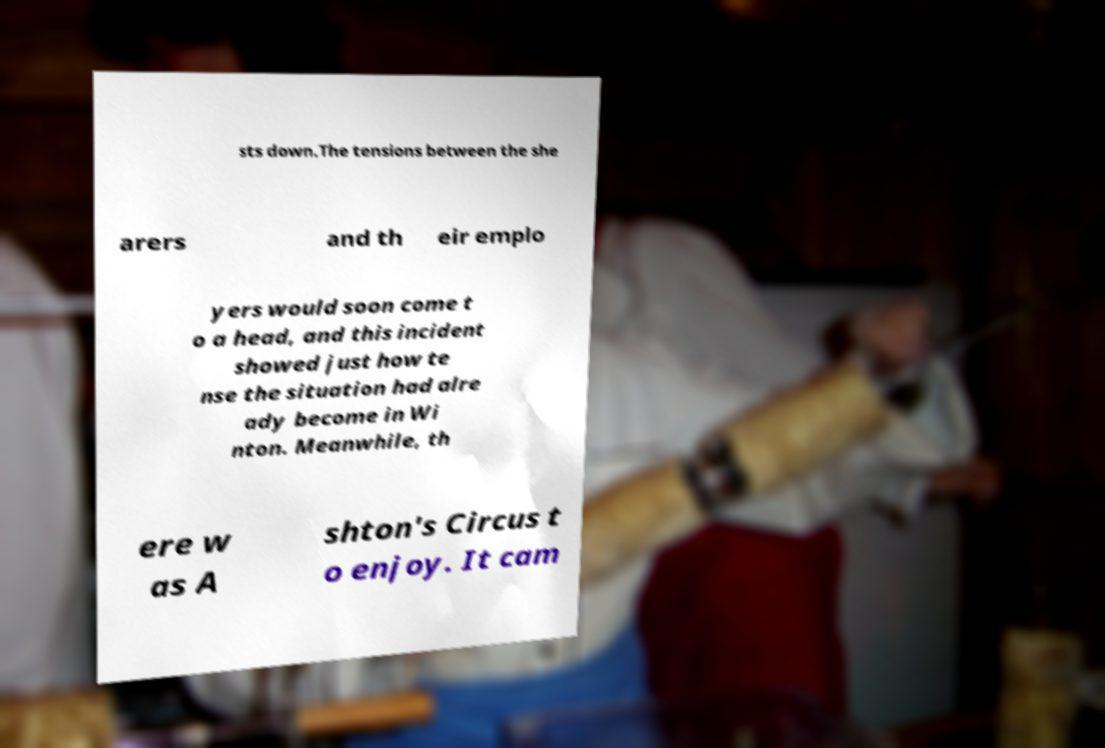For documentation purposes, I need the text within this image transcribed. Could you provide that? sts down.The tensions between the she arers and th eir emplo yers would soon come t o a head, and this incident showed just how te nse the situation had alre ady become in Wi nton. Meanwhile, th ere w as A shton's Circus t o enjoy. It cam 